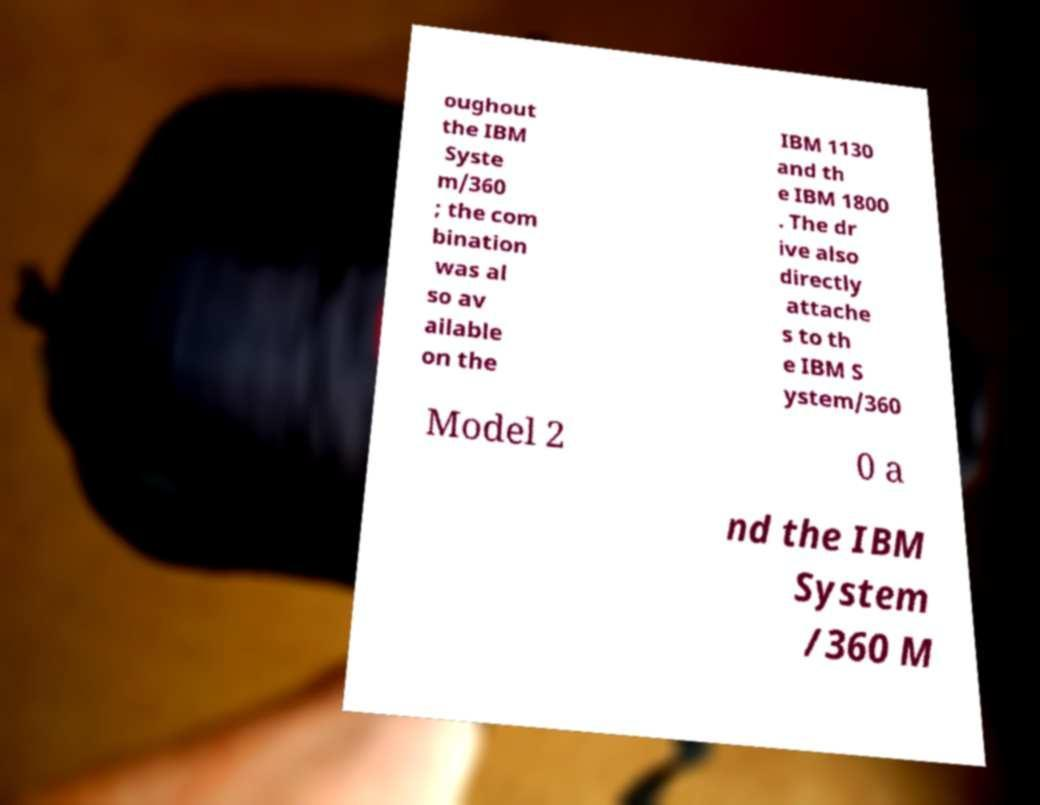Can you accurately transcribe the text from the provided image for me? oughout the IBM Syste m/360 ; the com bination was al so av ailable on the IBM 1130 and th e IBM 1800 . The dr ive also directly attache s to th e IBM S ystem/360 Model 2 0 a nd the IBM System /360 M 